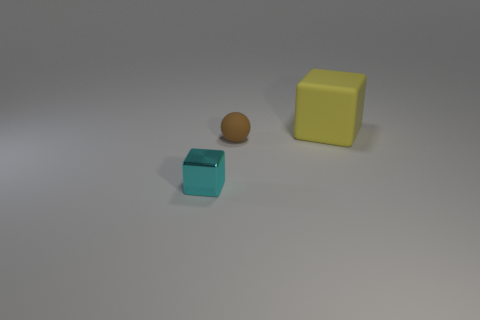Is the big yellow thing made of the same material as the cube that is in front of the matte cube?
Your answer should be very brief. No. Are there more big blocks that are behind the tiny brown rubber thing than tiny purple things?
Offer a very short reply. Yes. Is there anything else that has the same size as the yellow thing?
Your response must be concise. No. Are there an equal number of objects in front of the small cube and rubber blocks to the right of the sphere?
Your answer should be very brief. No. What is the small object that is behind the metallic block made of?
Your answer should be compact. Rubber. What number of objects are tiny brown rubber spheres that are right of the tiny cyan thing or big purple blocks?
Keep it short and to the point. 1. What number of other things are the same shape as the small brown rubber object?
Provide a succinct answer. 0. There is a thing behind the small brown rubber ball; is its shape the same as the cyan shiny thing?
Make the answer very short. Yes. Are there any large yellow blocks on the right side of the small brown rubber ball?
Make the answer very short. Yes. What number of large objects are matte blocks or balls?
Give a very brief answer. 1. 